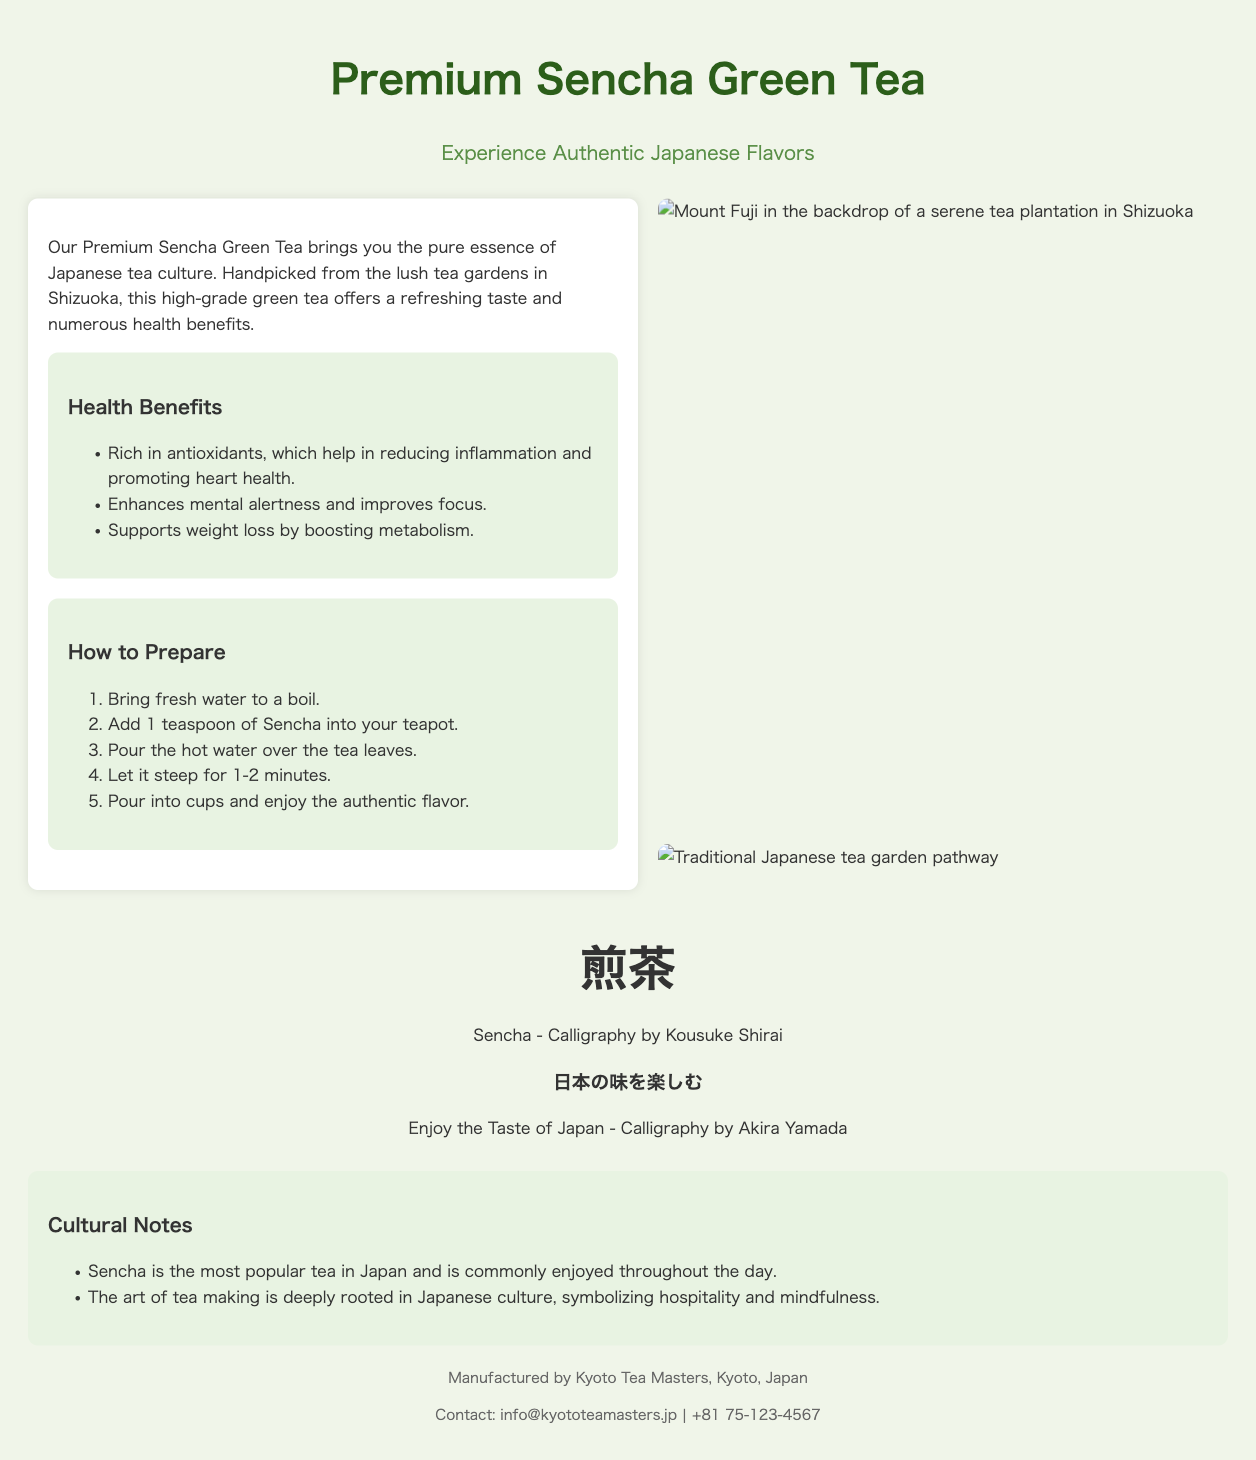What is the name of the tea featured? The title of the product is prominently displayed as "Premium Sencha Green Tea."
Answer: Premium Sencha Green Tea Where is this green tea sourced from? The document mentions that the tea is handpicked from the lush tea gardens in Shizuoka.
Answer: Shizuoka What are the health benefits listed? The document outlines several health benefits, including richness in antioxidants and mental alertness enhancement.
Answer: Antioxidants How long should Sencha steep? The usage instructions specify that Sencha should steep for 1-2 minutes.
Answer: 1-2 minutes Who created the calligraphy for "Sencha"? The document credits Kousuke Shirai for the calligraphy of "Sencha."
Answer: Kousuke Shirai What imagery is used to depict Japanese scenery? The product packaging includes images related to scenic Japanese locations like Mount Fuji and tea gardens.
Answer: Mount Fuji What is mentioned about Sencha in Japanese culture? The cultural notes in the document highlight that Sencha is the most popular tea in Japan.
Answer: Most popular tea Who is the manufacturer of this green tea? The manufacturer information indicates that it is made by Kyoto Tea Masters.
Answer: Kyoto Tea Masters 